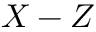Convert formula to latex. <formula><loc_0><loc_0><loc_500><loc_500>X - Z</formula> 